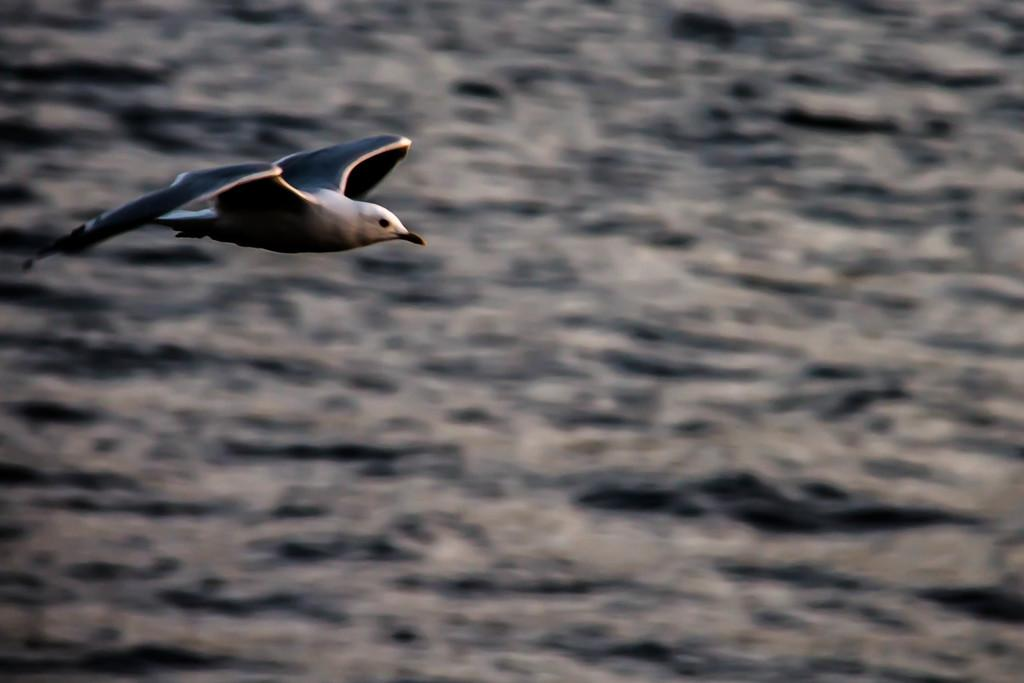What type of animal can be seen in the image? There is a bird in the image. What is the bird doing in the image? The bird is flying above the water surface. How many rabbits can be seen swimming in the water in the image? There are no rabbits present in the image, and they are not swimming in the water. What type of insect can be seen buzzing around the bird in the image? There are no insects, such as bees, present in the image. 